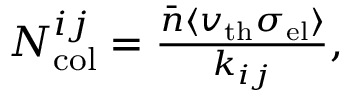<formula> <loc_0><loc_0><loc_500><loc_500>\begin{array} { r } { N _ { c o l } ^ { i j } = \frac { \bar { n } \langle v _ { t h } \sigma _ { e l } \rangle } { k _ { i j } } , } \end{array}</formula> 